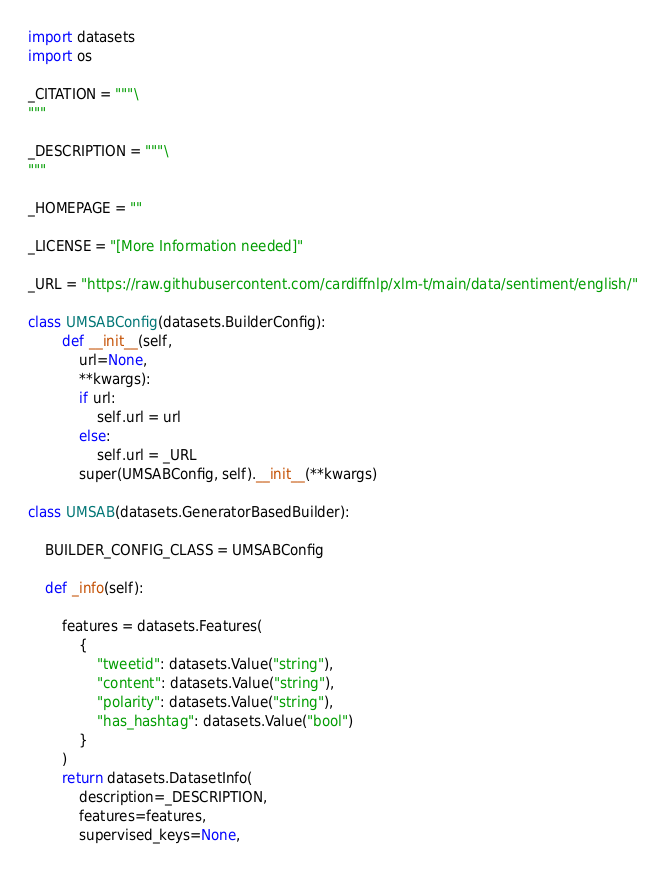<code> <loc_0><loc_0><loc_500><loc_500><_Python_>import datasets
import os

_CITATION = """\
"""

_DESCRIPTION = """\
"""

_HOMEPAGE = ""

_LICENSE = "[More Information needed]"

_URL = "https://raw.githubusercontent.com/cardiffnlp/xlm-t/main/data/sentiment/english/"

class UMSABConfig(datasets.BuilderConfig):
        def __init__(self, 
            url=None,
            **kwargs):
            if url:
                self.url = url
            else:
                self.url = _URL
            super(UMSABConfig, self).__init__(**kwargs)

class UMSAB(datasets.GeneratorBasedBuilder):

    BUILDER_CONFIG_CLASS = UMSABConfig

    def _info(self):
            
        features = datasets.Features(
            {
                "tweetid": datasets.Value("string"),
                "content": datasets.Value("string"),
                "polarity": datasets.Value("string"),
                "has_hashtag": datasets.Value("bool")
            }
        )
        return datasets.DatasetInfo(
            description=_DESCRIPTION,
            features=features,
            supervised_keys=None,</code> 